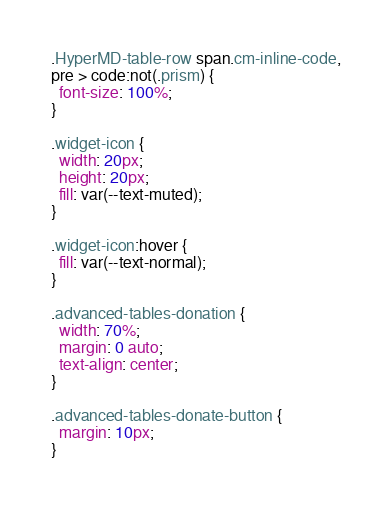<code> <loc_0><loc_0><loc_500><loc_500><_CSS_>.HyperMD-table-row span.cm-inline-code,
pre > code:not(.prism) {
  font-size: 100%;
}

.widget-icon {
  width: 20px;
  height: 20px;
  fill: var(--text-muted);
}

.widget-icon:hover {
  fill: var(--text-normal);
}

.advanced-tables-donation {
  width: 70%;
  margin: 0 auto;
  text-align: center;
}

.advanced-tables-donate-button {
  margin: 10px;
}
</code> 